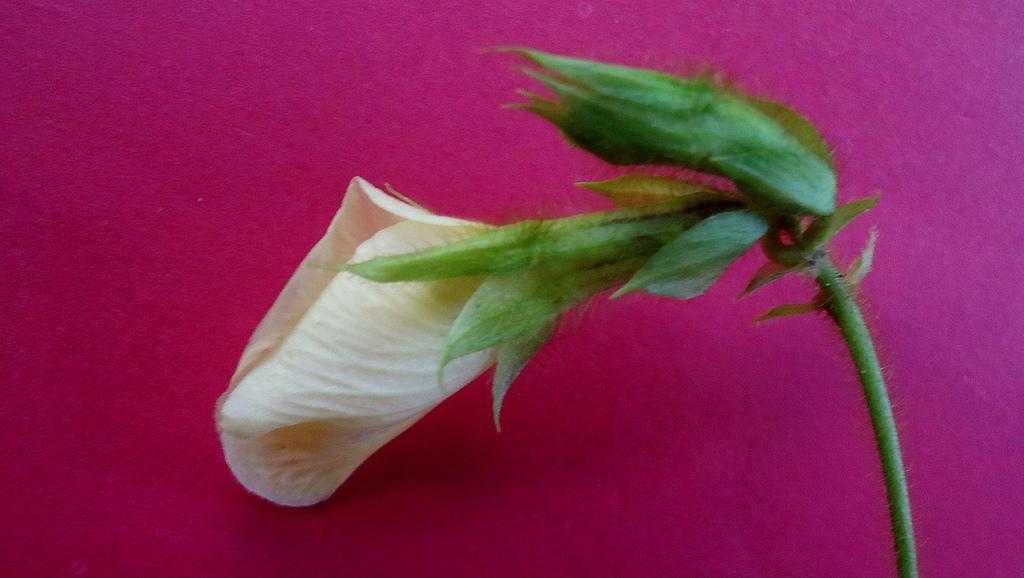How would you summarize this image in a sentence or two? It is a flower. 